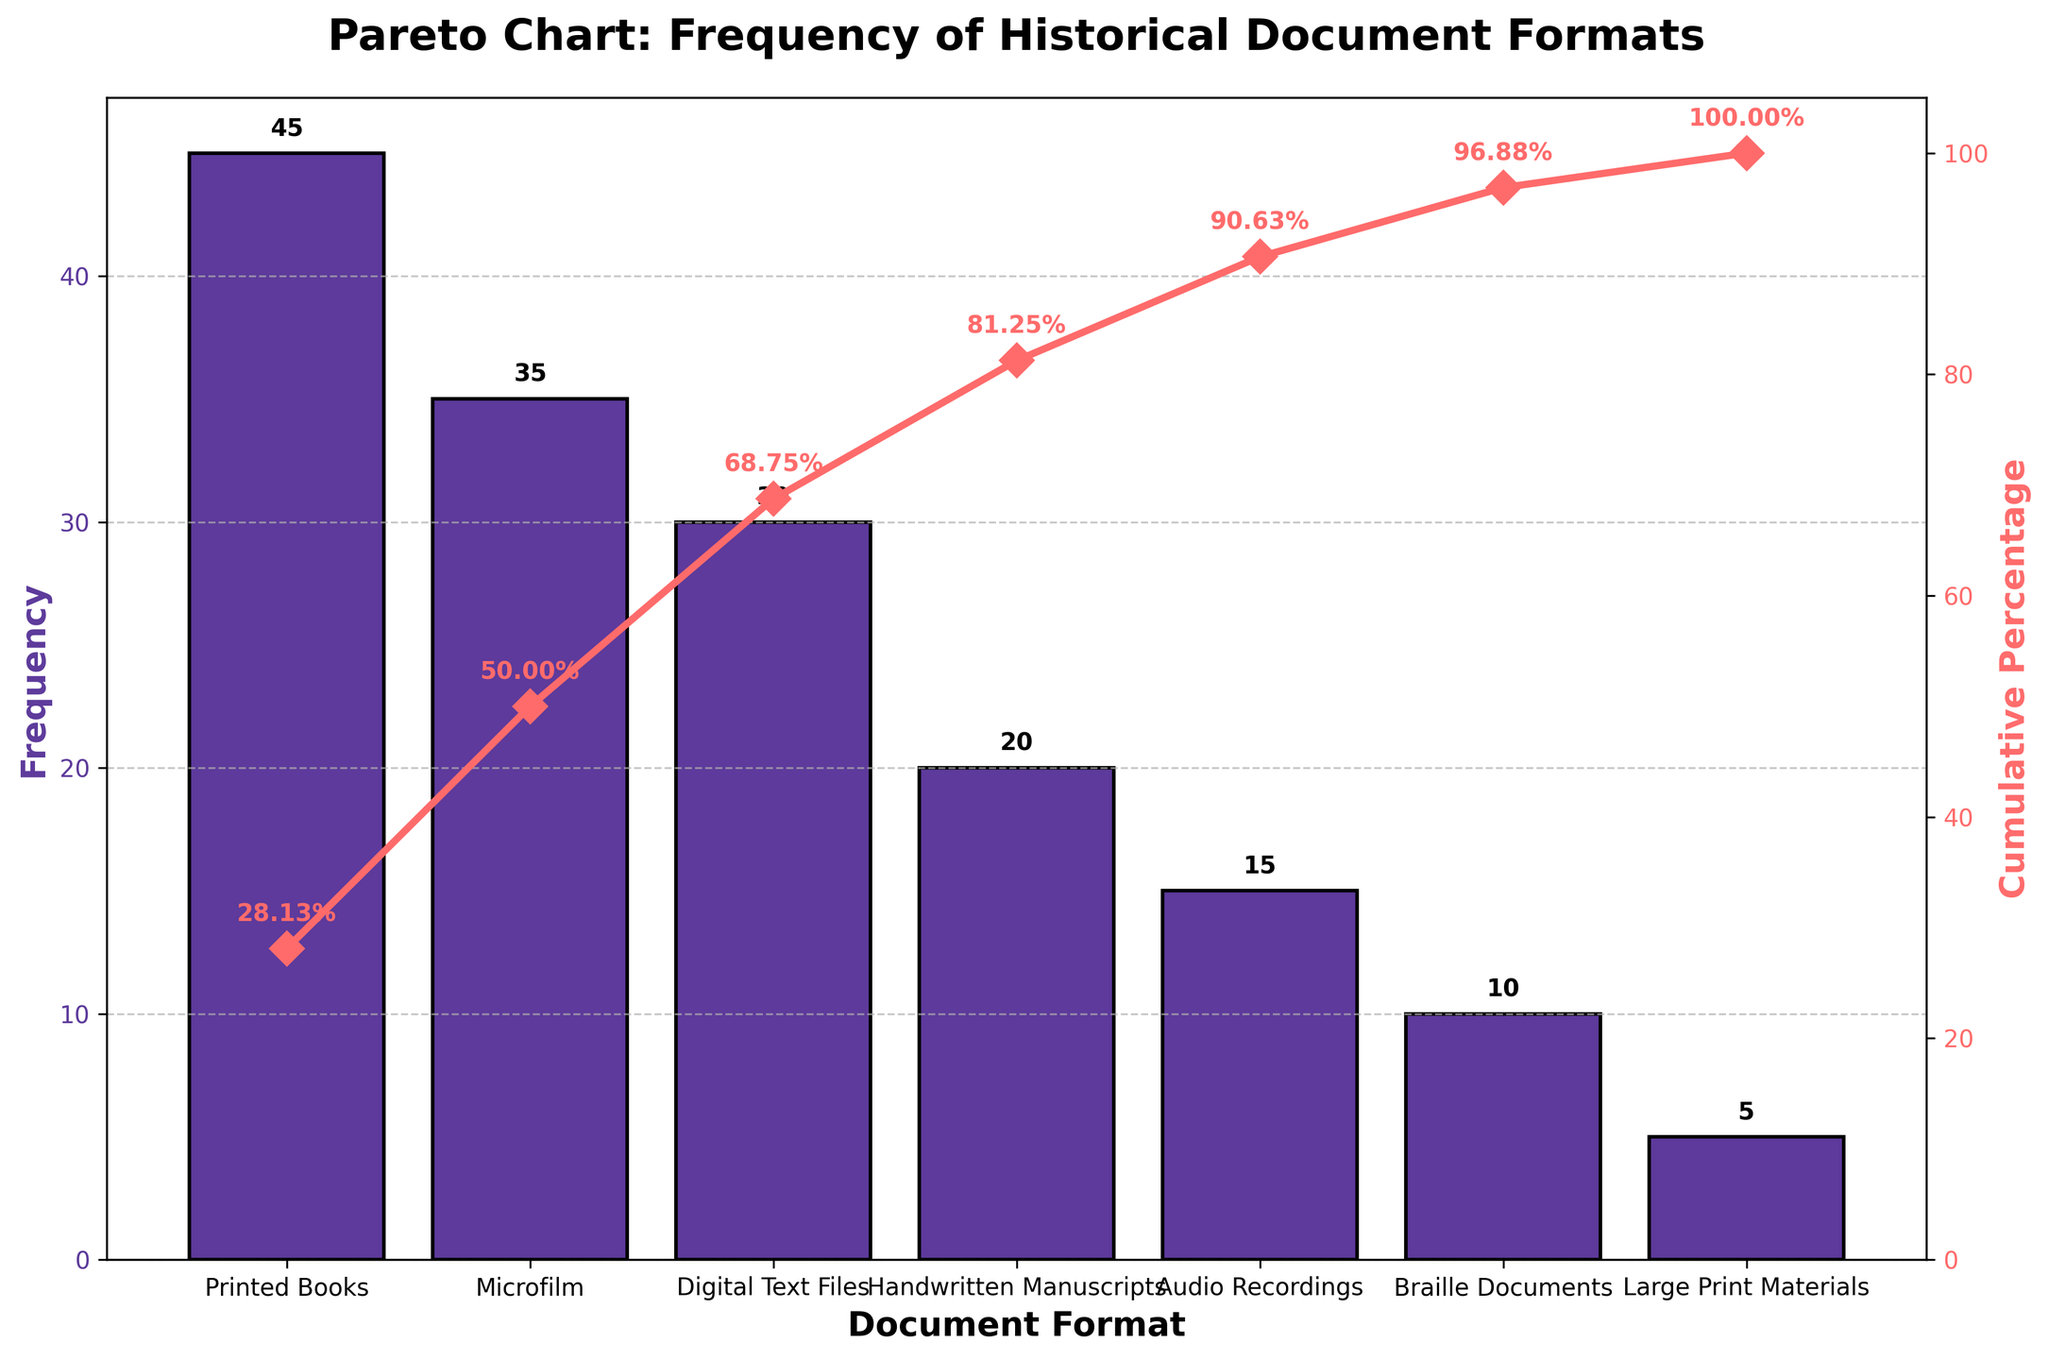What's the title of the chart? The title is prominently displayed at the top of the figure in bold text.
Answer: Pareto Chart: Frequency of Historical Document Formats What is the format with the highest frequency? The highest bar represents the format with the highest frequency.
Answer: Printed Books What is the cumulative percentage after Microfilm? The cumulative percentage line for Microfilm reaches up to a specific value on the secondary y-axis, annotated on the chart.
Answer: 50.00% Which document format has the lowest frequency? The smallest bar represents the format with the lowest frequency.
Answer: Large Print Materials What is the cumulative percentage for Digital Text Files? The point on the cumulative percentage line corresponding to Digital Text Files is labeled.
Answer: 68.75% How many document formats are plotted in the chart? Count the number of distinct bars in the bar chart.
Answer: 7 What is the difference in frequency between Printed Books and Audio Recordings? Subtract the frequency of Audio Recordings from the frequency of Printed Books.
Answer: 30 Which document formats have a frequency higher than 20? Identify all bars with heights corresponding to frequencies above 20.
Answer: Printed Books, Microfilm, Digital Text Files What's the cumulative percentage just before Braille Documents? Find the cumulative percentage value preceding the point for Braille Documents.
Answer: 90.63% Comparing Braille Documents and Large Print Materials, which format contributes more to the cumulative percentage and by how much? Subtract the cumulative percentage of Large Print Materials from Braille Documents.
Answer: 6.25% 